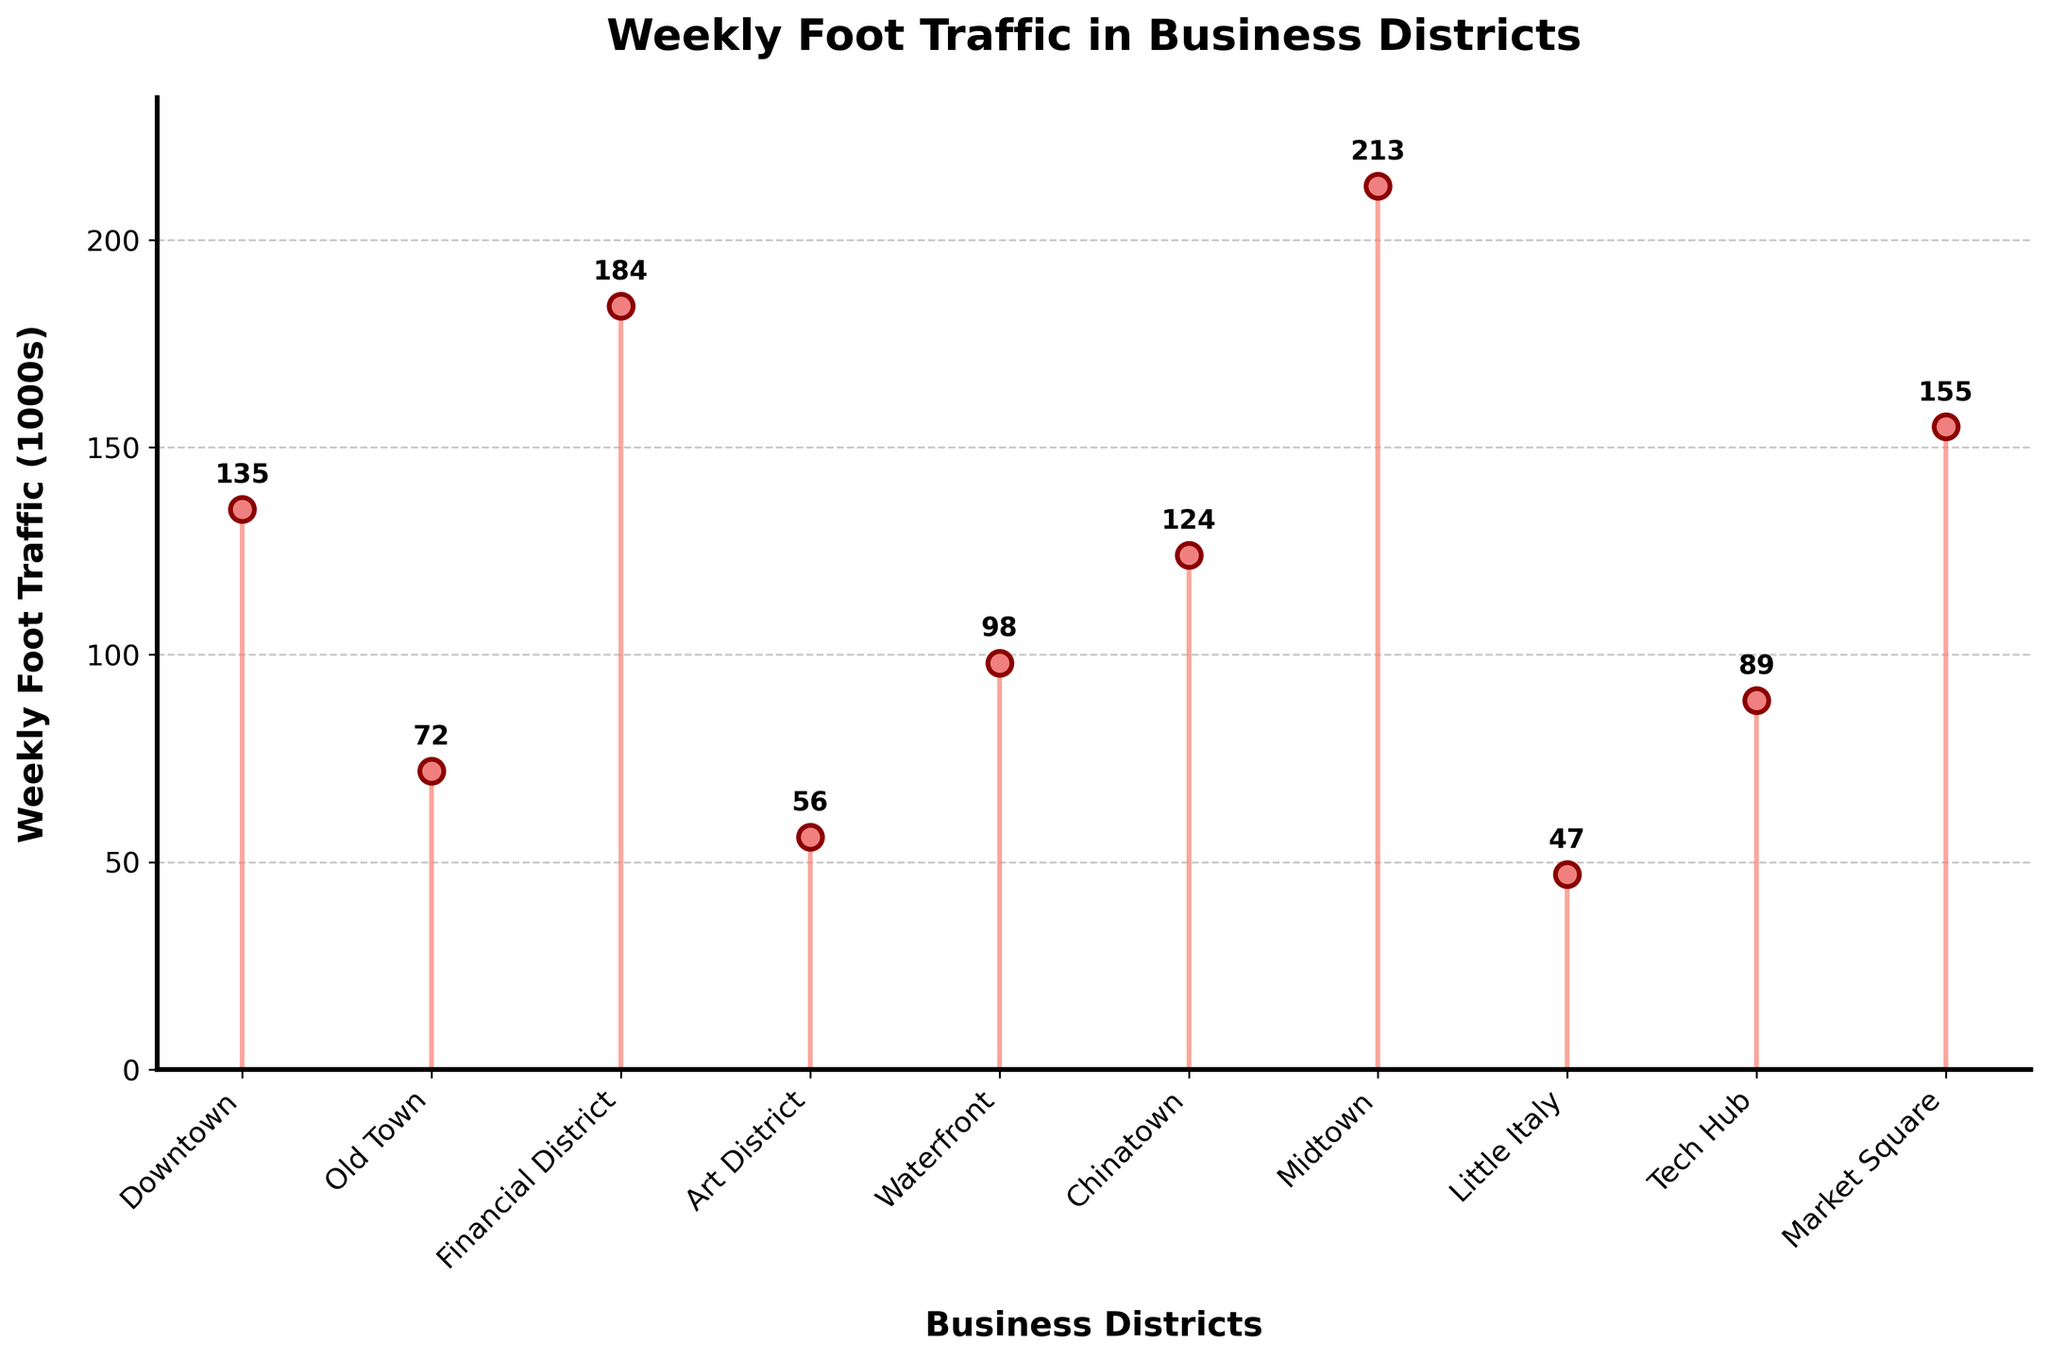What's the title of the figure? The title is usually found at the top of the figure and is meant to give an overview of what the figure represents. In this case, it reads "Weekly Foot Traffic in Business Districts"
Answer: Weekly Foot Traffic in Business Districts What is the weekly foot traffic in Midtown? By locating the "Midtown" label on the horizontal axis and following it up to the corresponding data point, you can see the numerical value indicated. Additionally, the exact value is labeled above the corresponding stem.
Answer: 213 (1000s) Which business district has the lowest weekly foot traffic? Among all the stems, the shortest one represents the lowest value. The corresponding label for this shortest stem is "Little Italy."
Answer: Little Italy How much higher is the foot traffic in Financial District compared to Art District? To find this, identify the values for Financial District (184) and Art District (56) from the stems. Subtract the smaller value from the larger one: 184 - 56.
Answer: 128 (1000s) What is the average weekly foot traffic across all business districts? Sum up all foot traffic values (135 + 72 + 184 + 56 + 98 + 124 + 213 + 47 + 89 + 155 = 1173). Then, divide by the number of districts (10).
Answer: 117.3 (1000s) Which business district has foot traffic closest to 100,000? Identify the district with a weekly foot traffic number closest to 100 by visually comparing all points to the value of 100. "Waterfront" with a value of 98 is the closest.
Answer: Waterfront How many business districts have weekly foot traffic greater than 100,000? Count the number of stems exceeding the horizontal line at the foot traffic value of 100. Districts: Downtown, Financial District, Chinatown, Midtown, Market Square. There are 5 such districts.
Answer: 5 What is the difference in weekly foot traffic between the Tech Hub and Chinatown? Locate the values for both districts: Tech Hub (89) and Chinatown (124). Subtract the smaller value from the larger one: 124 - 89.
Answer: 35 (1000s) What color are the markers representing weekly foot traffic? The markers are placed on top of the stems, and their color is described as 'lightcoral' in the explanation.
Answer: Lightcoral How does the Financial District's foot traffic compare with Market Square? Identify both values: Financial District (184) and Market Square (155). Financial District's value is higher than Market Square's.
Answer: Financial District has higher foot traffic than Market Square 